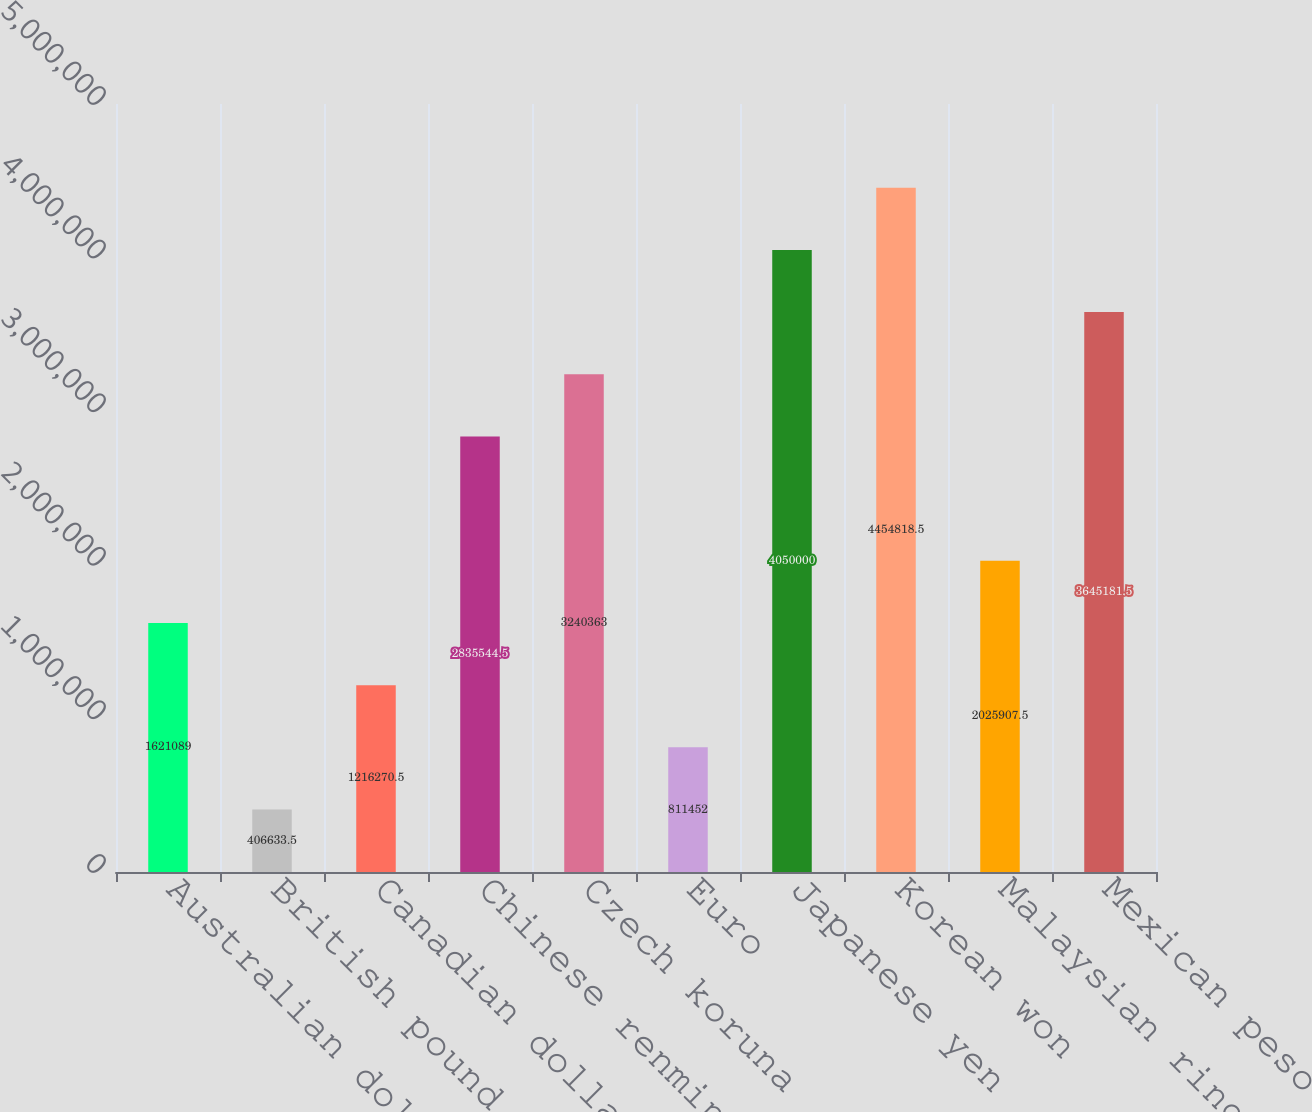Convert chart to OTSL. <chart><loc_0><loc_0><loc_500><loc_500><bar_chart><fcel>Australian dollar<fcel>British pound<fcel>Canadian dollar<fcel>Chinese renminbi<fcel>Czech koruna<fcel>Euro<fcel>Japanese yen<fcel>Korean won<fcel>Malaysian ringgit<fcel>Mexican peso<nl><fcel>1.62109e+06<fcel>406634<fcel>1.21627e+06<fcel>2.83554e+06<fcel>3.24036e+06<fcel>811452<fcel>4.05e+06<fcel>4.45482e+06<fcel>2.02591e+06<fcel>3.64518e+06<nl></chart> 